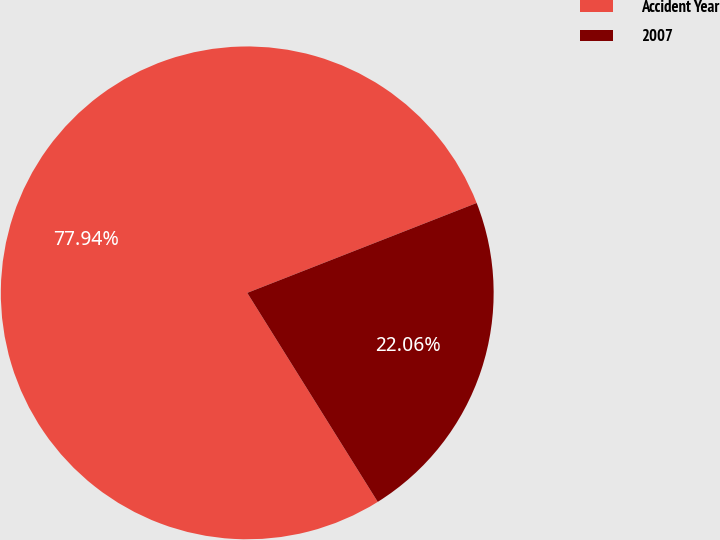<chart> <loc_0><loc_0><loc_500><loc_500><pie_chart><fcel>Accident Year<fcel>2007<nl><fcel>77.94%<fcel>22.06%<nl></chart> 